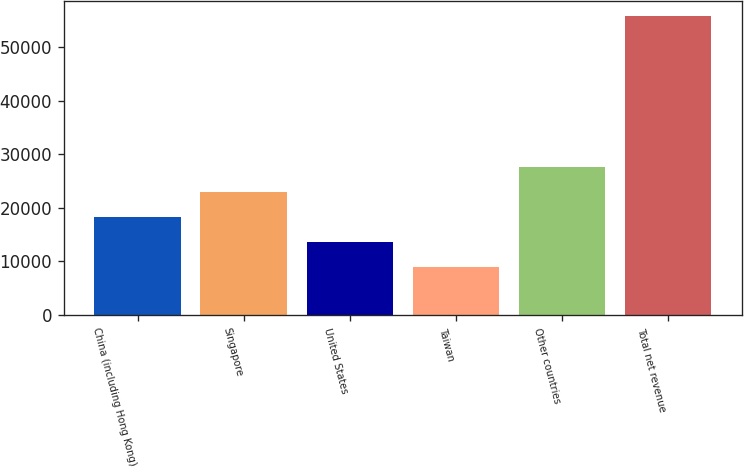<chart> <loc_0><loc_0><loc_500><loc_500><bar_chart><fcel>China (including Hong Kong)<fcel>Singapore<fcel>United States<fcel>Taiwan<fcel>Other countries<fcel>Total net revenue<nl><fcel>18338<fcel>23029.5<fcel>13646.5<fcel>8955<fcel>27721<fcel>55870<nl></chart> 